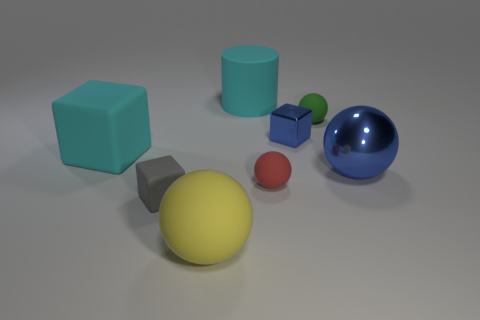What number of green objects are the same size as the blue cube? 1 